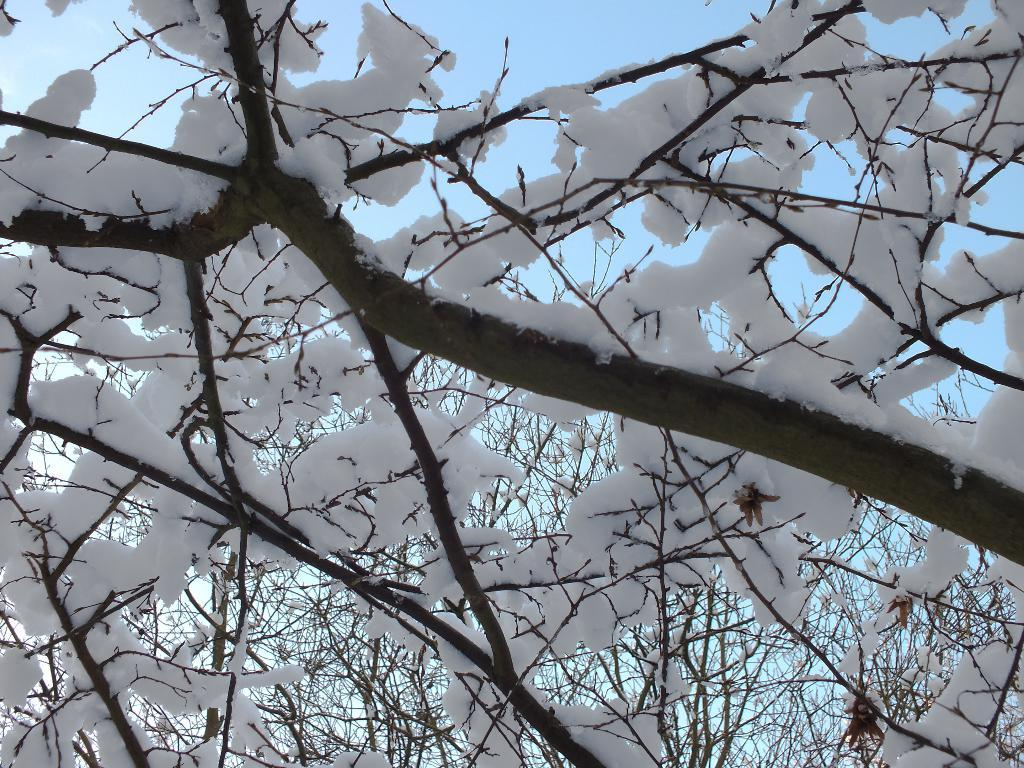What type of vegetation can be seen in the image? There are trees in the image. What is the weather like in the image? There is snow visible in the image, which suggests a cold or wintery environment. How many oranges are hanging from the trees in the image? There are no oranges present in the image; it features trees with snow. What type of board can be seen being used for a game in the image? There is no board or game present in the image; it only shows trees and snow. 